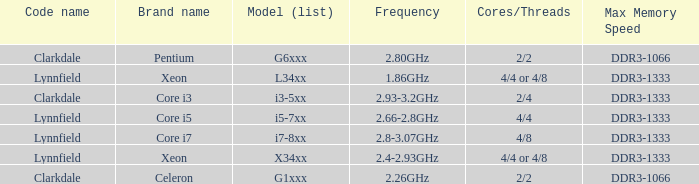What is the maximum memory speed for frequencies between 2.93-3.2ghz? DDR3-1333. 